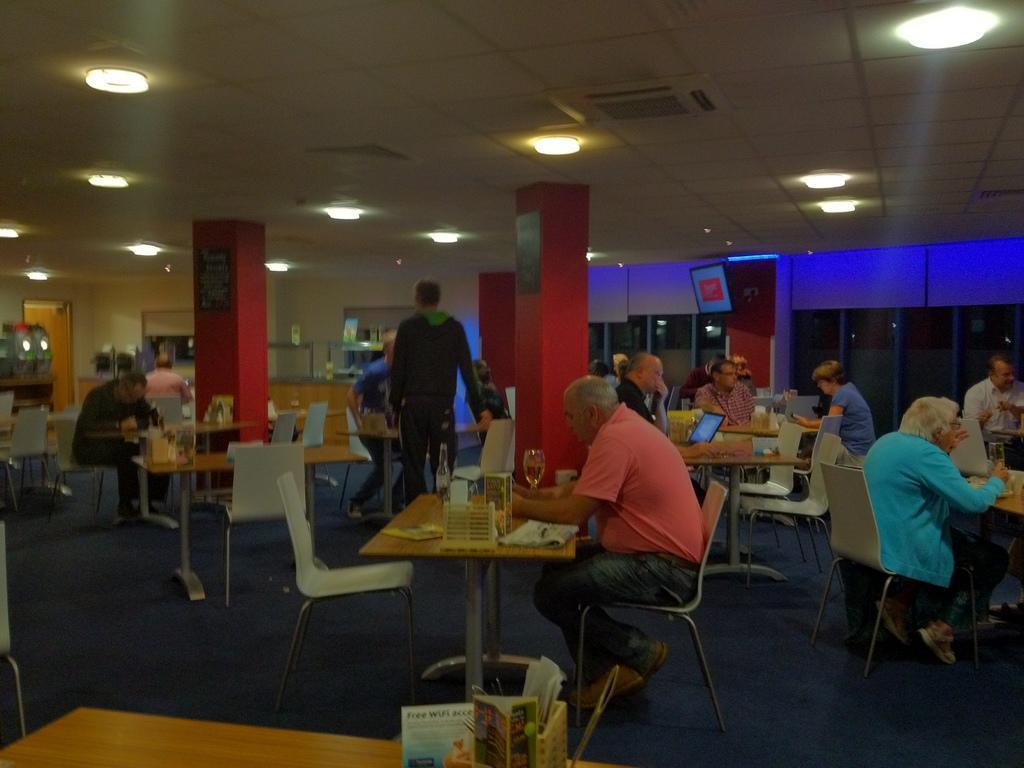In one or two sentences, can you explain what this image depicts? In the picture we can find tables, chairs and some people sitting on it. We can also find pillars and it is in red in color. And ceiling is filled with lights and the floor is in blue in color. And we can see a person who is sitting first is having a food and is wearing a orange color T-shirt and next to him there is one more person wearing a blue shirt. In the background we can see glass walls and blue lights. 